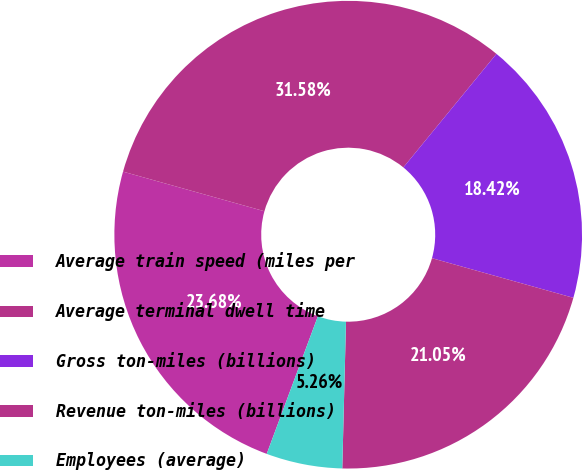<chart> <loc_0><loc_0><loc_500><loc_500><pie_chart><fcel>Average train speed (miles per<fcel>Average terminal dwell time<fcel>Gross ton-miles (billions)<fcel>Revenue ton-miles (billions)<fcel>Employees (average)<nl><fcel>23.68%<fcel>31.58%<fcel>18.42%<fcel>21.05%<fcel>5.26%<nl></chart> 